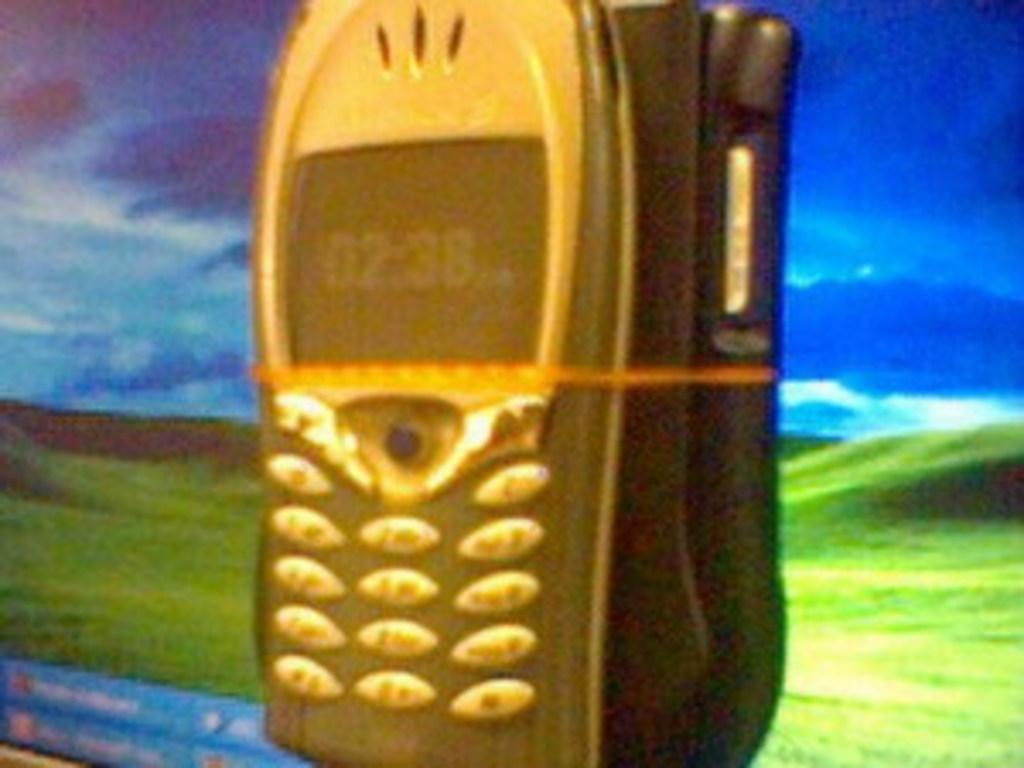What type of image is being described? The image is an animation and graphic. What is the main object in the center of the image? There is a mobile phone in the center of the image. What can be seen in the background of the image? There is grass on the ground and a cloudy sky in the background. What is the purpose of the cemetery in the image? There is no cemetery present in the image; it features an animation and graphic with a mobile phone in the center and a grassy background with a cloudy sky. 